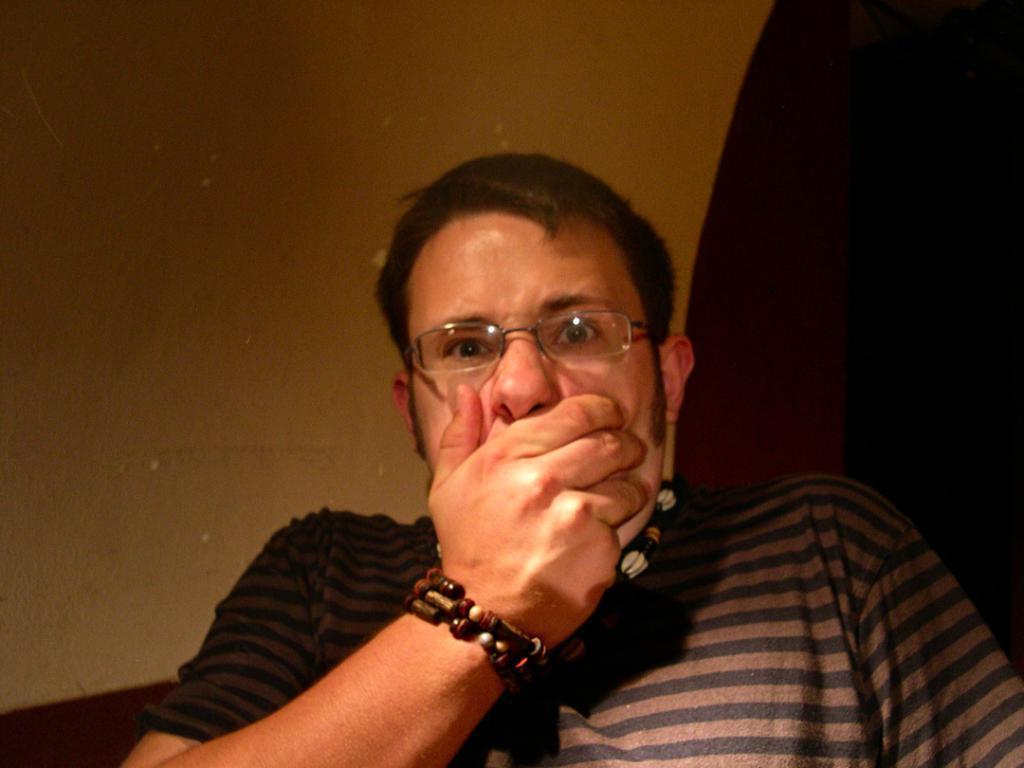Could you give a brief overview of what you see in this image? In this image in the front there is a person. In the background there is a wall. 